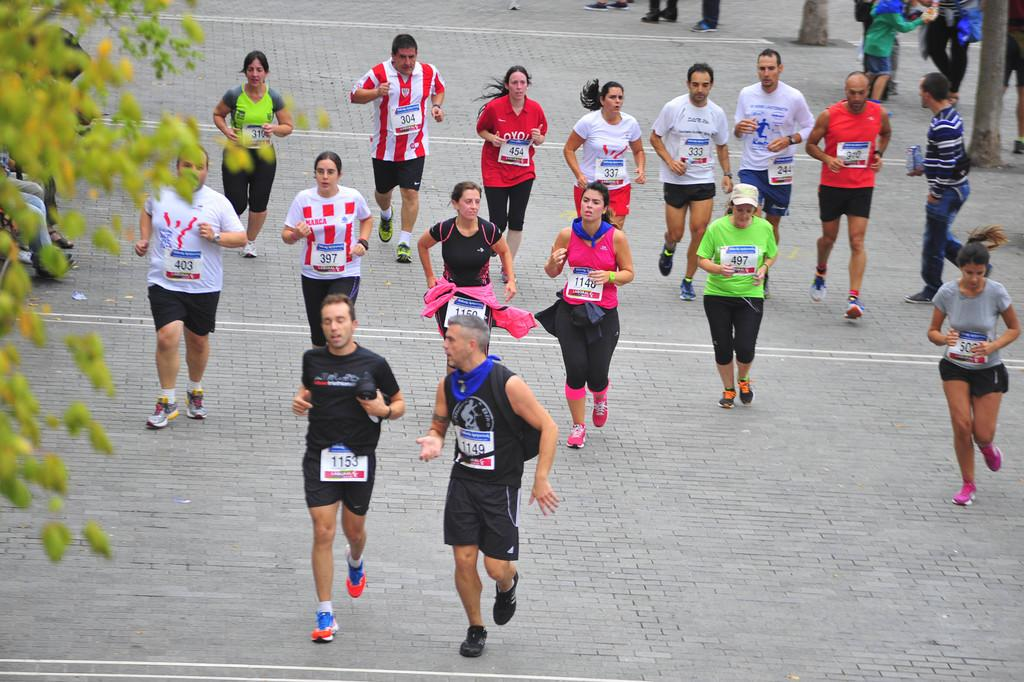What is happening in the image involving the group of people? Some people are running, and some people are standing. Can you describe the setting of the image? There are trees in the image. Is there a tiger hiding behind the trees in the image? No, there is no tiger present in the image. What type of ornament can be seen hanging from the branches of the trees? There are no ornaments visible in the image; only trees are present. 